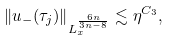<formula> <loc_0><loc_0><loc_500><loc_500>\left \| u _ { - } ( \tau _ { j } ) \right \| _ { L ^ { \frac { 6 n } { 3 n - 8 } } _ { x } } \lesssim \eta ^ { C _ { 3 } } ,</formula> 